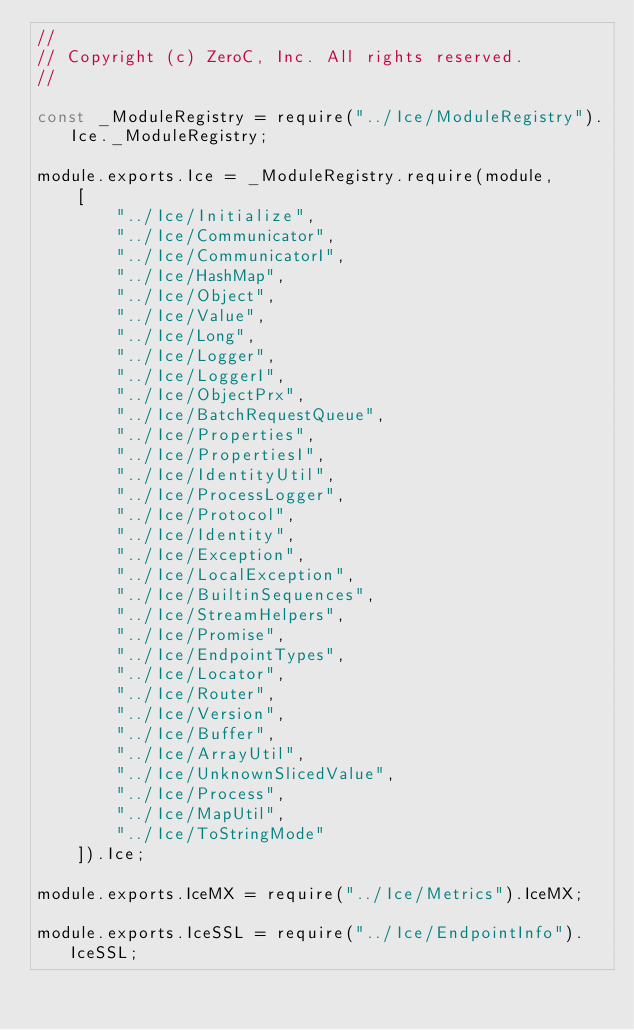<code> <loc_0><loc_0><loc_500><loc_500><_JavaScript_>//
// Copyright (c) ZeroC, Inc. All rights reserved.
//

const _ModuleRegistry = require("../Ice/ModuleRegistry").Ice._ModuleRegistry;

module.exports.Ice = _ModuleRegistry.require(module,
    [
        "../Ice/Initialize",
        "../Ice/Communicator",
        "../Ice/CommunicatorI",
        "../Ice/HashMap",
        "../Ice/Object",
        "../Ice/Value",
        "../Ice/Long",
        "../Ice/Logger",
        "../Ice/LoggerI",
        "../Ice/ObjectPrx",
        "../Ice/BatchRequestQueue",
        "../Ice/Properties",
        "../Ice/PropertiesI",
        "../Ice/IdentityUtil",
        "../Ice/ProcessLogger",
        "../Ice/Protocol",
        "../Ice/Identity",
        "../Ice/Exception",
        "../Ice/LocalException",
        "../Ice/BuiltinSequences",
        "../Ice/StreamHelpers",
        "../Ice/Promise",
        "../Ice/EndpointTypes",
        "../Ice/Locator",
        "../Ice/Router",
        "../Ice/Version",
        "../Ice/Buffer",
        "../Ice/ArrayUtil",
        "../Ice/UnknownSlicedValue",
        "../Ice/Process",
        "../Ice/MapUtil",
        "../Ice/ToStringMode"
    ]).Ice;

module.exports.IceMX = require("../Ice/Metrics").IceMX;

module.exports.IceSSL = require("../Ice/EndpointInfo").IceSSL;
</code> 